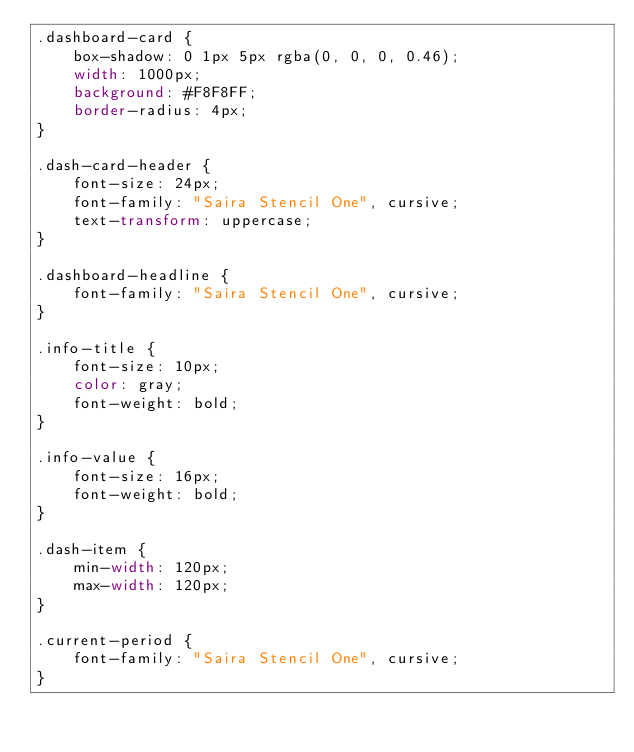Convert code to text. <code><loc_0><loc_0><loc_500><loc_500><_CSS_>.dashboard-card {
    box-shadow: 0 1px 5px rgba(0, 0, 0, 0.46);
    width: 1000px;
    background: #F8F8FF;
    border-radius: 4px;
}

.dash-card-header {
    font-size: 24px;
    font-family: "Saira Stencil One", cursive;
    text-transform: uppercase;
}

.dashboard-headline {
    font-family: "Saira Stencil One", cursive;
}

.info-title {
    font-size: 10px;
    color: gray;
    font-weight: bold;
}

.info-value {
    font-size: 16px;
    font-weight: bold;
}

.dash-item {
    min-width: 120px;
    max-width: 120px;
}

.current-period {
    font-family: "Saira Stencil One", cursive;
}</code> 